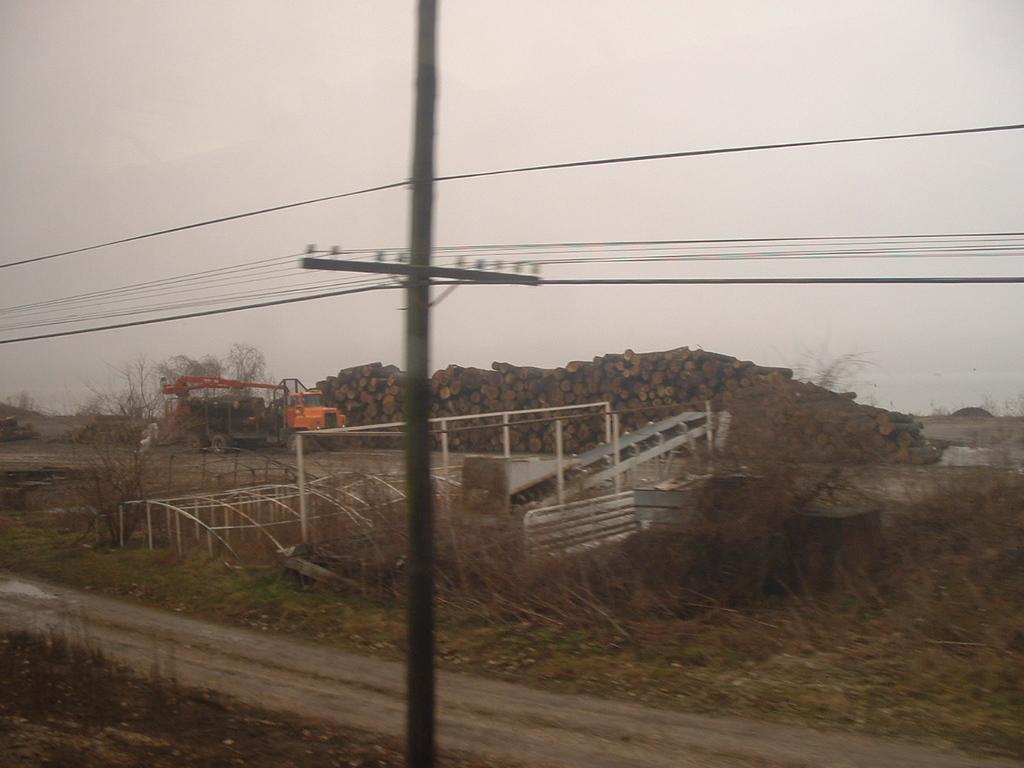Could you give a brief overview of what you see in this image? In this picture there is a vehicle and there are wooden logs. In the foreground there are metal objects and there is a pole and there are wires on the pole. At the top there is sky. At the bottom there is grass and there is ground. On the left side of the image there is water. At the back there are trees. 